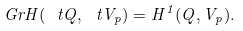<formula> <loc_0><loc_0><loc_500><loc_500>\ G r H ( \ t Q , \ t V _ { p } ) = H ^ { 1 } ( Q , V _ { p } ) .</formula> 